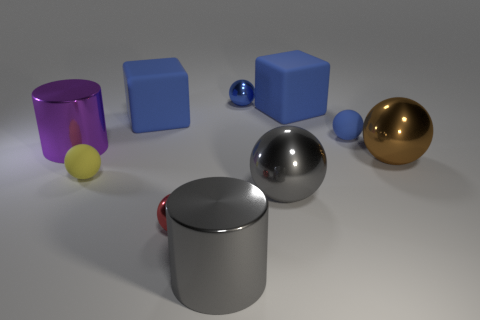Subtract all metal spheres. How many spheres are left? 2 Subtract all gray cylinders. How many blue spheres are left? 2 Subtract all gray spheres. How many spheres are left? 5 Subtract 3 balls. How many balls are left? 3 Subtract all blocks. How many objects are left? 8 Subtract all green balls. Subtract all brown cylinders. How many balls are left? 6 Add 1 small rubber balls. How many small rubber balls exist? 3 Subtract 1 yellow balls. How many objects are left? 9 Subtract all large metallic balls. Subtract all large brown objects. How many objects are left? 7 Add 5 tiny shiny spheres. How many tiny shiny spheres are left? 7 